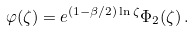Convert formula to latex. <formula><loc_0><loc_0><loc_500><loc_500>\varphi ( \zeta ) = e ^ { ( 1 - \beta / 2 ) \ln \zeta } \Phi _ { 2 } ( \zeta ) \, .</formula> 